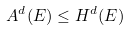<formula> <loc_0><loc_0><loc_500><loc_500>A ^ { d } ( E ) \leq H ^ { d } ( E )</formula> 